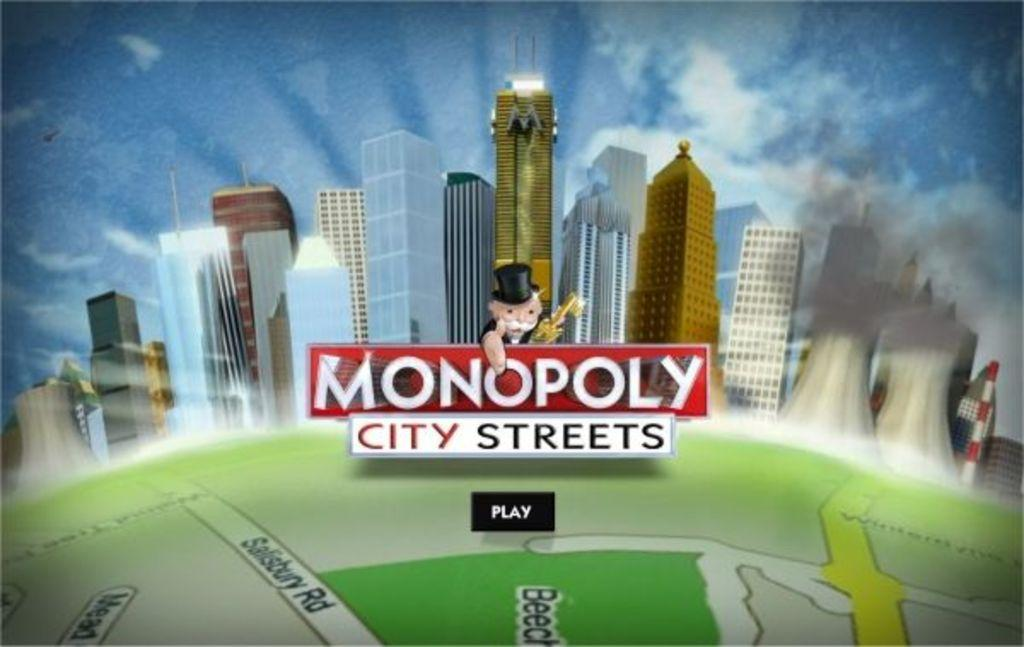Provide a one-sentence caption for the provided image. The front of a game box which shows a city vista and the monopoly money man who points to the words City Streets below him. 